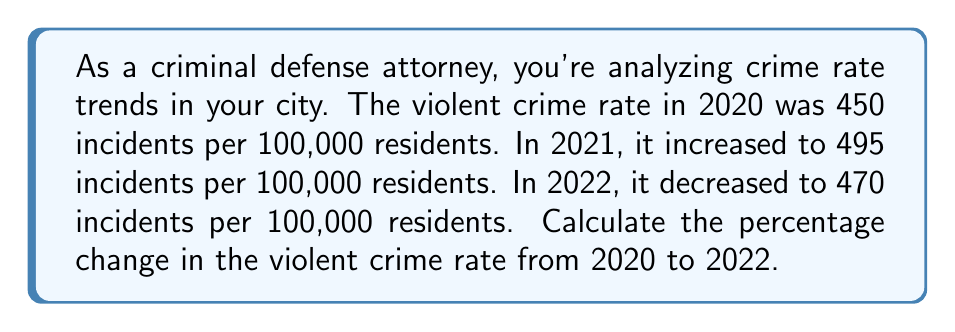Show me your answer to this math problem. To calculate the percentage change in the violent crime rate from 2020 to 2022, we'll use the formula:

$$ \text{Percentage Change} = \frac{\text{New Value} - \text{Original Value}}{\text{Original Value}} \times 100\% $$

1. Identify the values:
   - Original value (2020 rate): 450 incidents per 100,000 residents
   - New value (2022 rate): 470 incidents per 100,000 residents

2. Apply the formula:

   $$ \text{Percentage Change} = \frac{470 - 450}{450} \times 100\% $$

3. Simplify:
   $$ \text{Percentage Change} = \frac{20}{450} \times 100\% $$

4. Perform the division:
   $$ \text{Percentage Change} = 0.04444... \times 100\% $$

5. Convert to a percentage:
   $$ \text{Percentage Change} = 4.44\% $$

Therefore, the violent crime rate increased by approximately 4.44% from 2020 to 2022.
Answer: The percentage change in the violent crime rate from 2020 to 2022 is an increase of 4.44%. 